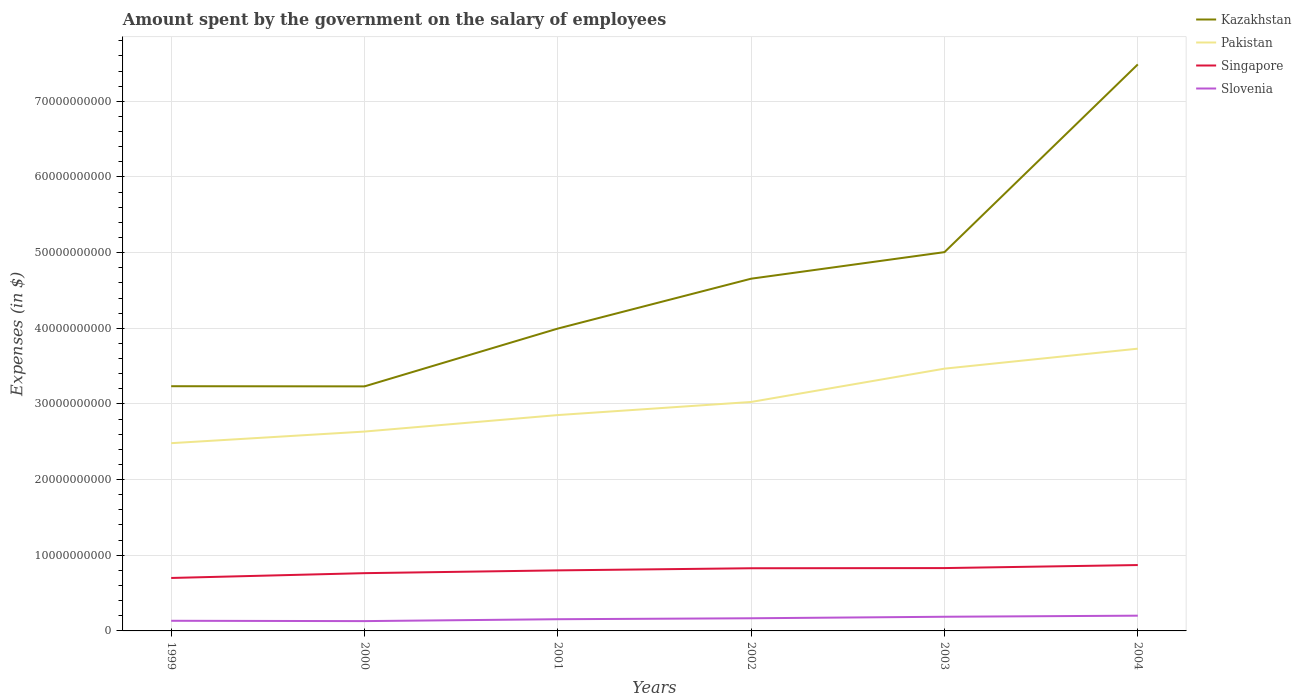How many different coloured lines are there?
Your answer should be compact. 4. Across all years, what is the maximum amount spent on the salary of employees by the government in Slovenia?
Offer a very short reply. 1.30e+09. What is the total amount spent on the salary of employees by the government in Singapore in the graph?
Your response must be concise. -6.35e+08. What is the difference between the highest and the second highest amount spent on the salary of employees by the government in Singapore?
Your response must be concise. 1.71e+09. Does the graph contain any zero values?
Provide a short and direct response. No. Does the graph contain grids?
Provide a short and direct response. Yes. How many legend labels are there?
Your answer should be very brief. 4. What is the title of the graph?
Provide a succinct answer. Amount spent by the government on the salary of employees. Does "Pakistan" appear as one of the legend labels in the graph?
Make the answer very short. Yes. What is the label or title of the X-axis?
Provide a succinct answer. Years. What is the label or title of the Y-axis?
Keep it short and to the point. Expenses (in $). What is the Expenses (in $) of Kazakhstan in 1999?
Ensure brevity in your answer.  3.23e+1. What is the Expenses (in $) in Pakistan in 1999?
Your answer should be compact. 2.48e+1. What is the Expenses (in $) in Singapore in 1999?
Offer a very short reply. 7.00e+09. What is the Expenses (in $) in Slovenia in 1999?
Provide a short and direct response. 1.34e+09. What is the Expenses (in $) in Kazakhstan in 2000?
Give a very brief answer. 3.23e+1. What is the Expenses (in $) in Pakistan in 2000?
Your answer should be very brief. 2.64e+1. What is the Expenses (in $) of Singapore in 2000?
Offer a very short reply. 7.63e+09. What is the Expenses (in $) of Slovenia in 2000?
Give a very brief answer. 1.30e+09. What is the Expenses (in $) in Kazakhstan in 2001?
Make the answer very short. 4.00e+1. What is the Expenses (in $) of Pakistan in 2001?
Your response must be concise. 2.85e+1. What is the Expenses (in $) of Singapore in 2001?
Make the answer very short. 8.00e+09. What is the Expenses (in $) of Slovenia in 2001?
Provide a short and direct response. 1.55e+09. What is the Expenses (in $) in Kazakhstan in 2002?
Provide a short and direct response. 4.66e+1. What is the Expenses (in $) of Pakistan in 2002?
Your response must be concise. 3.03e+1. What is the Expenses (in $) in Singapore in 2002?
Offer a very short reply. 8.28e+09. What is the Expenses (in $) in Slovenia in 2002?
Your answer should be very brief. 1.67e+09. What is the Expenses (in $) of Kazakhstan in 2003?
Provide a short and direct response. 5.01e+1. What is the Expenses (in $) of Pakistan in 2003?
Offer a terse response. 3.47e+1. What is the Expenses (in $) in Singapore in 2003?
Make the answer very short. 8.31e+09. What is the Expenses (in $) of Slovenia in 2003?
Provide a succinct answer. 1.87e+09. What is the Expenses (in $) of Kazakhstan in 2004?
Provide a succinct answer. 7.49e+1. What is the Expenses (in $) of Pakistan in 2004?
Provide a succinct answer. 3.73e+1. What is the Expenses (in $) in Singapore in 2004?
Your answer should be very brief. 8.71e+09. What is the Expenses (in $) in Slovenia in 2004?
Provide a succinct answer. 2.02e+09. Across all years, what is the maximum Expenses (in $) in Kazakhstan?
Keep it short and to the point. 7.49e+1. Across all years, what is the maximum Expenses (in $) in Pakistan?
Offer a very short reply. 3.73e+1. Across all years, what is the maximum Expenses (in $) in Singapore?
Provide a succinct answer. 8.71e+09. Across all years, what is the maximum Expenses (in $) in Slovenia?
Offer a very short reply. 2.02e+09. Across all years, what is the minimum Expenses (in $) in Kazakhstan?
Ensure brevity in your answer.  3.23e+1. Across all years, what is the minimum Expenses (in $) in Pakistan?
Offer a terse response. 2.48e+1. Across all years, what is the minimum Expenses (in $) of Singapore?
Make the answer very short. 7.00e+09. Across all years, what is the minimum Expenses (in $) in Slovenia?
Your answer should be very brief. 1.30e+09. What is the total Expenses (in $) in Kazakhstan in the graph?
Offer a very short reply. 2.76e+11. What is the total Expenses (in $) in Pakistan in the graph?
Provide a short and direct response. 1.82e+11. What is the total Expenses (in $) of Singapore in the graph?
Keep it short and to the point. 4.79e+1. What is the total Expenses (in $) of Slovenia in the graph?
Your answer should be compact. 9.75e+09. What is the difference between the Expenses (in $) in Kazakhstan in 1999 and that in 2000?
Provide a succinct answer. 2.18e+07. What is the difference between the Expenses (in $) of Pakistan in 1999 and that in 2000?
Keep it short and to the point. -1.54e+09. What is the difference between the Expenses (in $) of Singapore in 1999 and that in 2000?
Offer a terse response. -6.35e+08. What is the difference between the Expenses (in $) in Slovenia in 1999 and that in 2000?
Your response must be concise. 4.36e+07. What is the difference between the Expenses (in $) of Kazakhstan in 1999 and that in 2001?
Your answer should be compact. -7.62e+09. What is the difference between the Expenses (in $) of Pakistan in 1999 and that in 2001?
Your answer should be compact. -3.72e+09. What is the difference between the Expenses (in $) of Singapore in 1999 and that in 2001?
Your response must be concise. -1.00e+09. What is the difference between the Expenses (in $) of Slovenia in 1999 and that in 2001?
Provide a succinct answer. -2.05e+08. What is the difference between the Expenses (in $) of Kazakhstan in 1999 and that in 2002?
Give a very brief answer. -1.42e+1. What is the difference between the Expenses (in $) of Pakistan in 1999 and that in 2002?
Make the answer very short. -5.45e+09. What is the difference between the Expenses (in $) in Singapore in 1999 and that in 2002?
Offer a very short reply. -1.28e+09. What is the difference between the Expenses (in $) of Slovenia in 1999 and that in 2002?
Give a very brief answer. -3.32e+08. What is the difference between the Expenses (in $) of Kazakhstan in 1999 and that in 2003?
Give a very brief answer. -1.77e+1. What is the difference between the Expenses (in $) of Pakistan in 1999 and that in 2003?
Offer a terse response. -9.85e+09. What is the difference between the Expenses (in $) of Singapore in 1999 and that in 2003?
Offer a terse response. -1.31e+09. What is the difference between the Expenses (in $) of Slovenia in 1999 and that in 2003?
Offer a very short reply. -5.33e+08. What is the difference between the Expenses (in $) of Kazakhstan in 1999 and that in 2004?
Your answer should be compact. -4.25e+1. What is the difference between the Expenses (in $) in Pakistan in 1999 and that in 2004?
Ensure brevity in your answer.  -1.25e+1. What is the difference between the Expenses (in $) in Singapore in 1999 and that in 2004?
Make the answer very short. -1.71e+09. What is the difference between the Expenses (in $) in Slovenia in 1999 and that in 2004?
Provide a short and direct response. -6.75e+08. What is the difference between the Expenses (in $) of Kazakhstan in 2000 and that in 2001?
Keep it short and to the point. -7.64e+09. What is the difference between the Expenses (in $) in Pakistan in 2000 and that in 2001?
Provide a short and direct response. -2.18e+09. What is the difference between the Expenses (in $) of Singapore in 2000 and that in 2001?
Offer a terse response. -3.69e+08. What is the difference between the Expenses (in $) in Slovenia in 2000 and that in 2001?
Give a very brief answer. -2.49e+08. What is the difference between the Expenses (in $) of Kazakhstan in 2000 and that in 2002?
Your answer should be compact. -1.42e+1. What is the difference between the Expenses (in $) of Pakistan in 2000 and that in 2002?
Offer a very short reply. -3.91e+09. What is the difference between the Expenses (in $) of Singapore in 2000 and that in 2002?
Ensure brevity in your answer.  -6.49e+08. What is the difference between the Expenses (in $) in Slovenia in 2000 and that in 2002?
Your answer should be compact. -3.76e+08. What is the difference between the Expenses (in $) of Kazakhstan in 2000 and that in 2003?
Give a very brief answer. -1.77e+1. What is the difference between the Expenses (in $) of Pakistan in 2000 and that in 2003?
Give a very brief answer. -8.32e+09. What is the difference between the Expenses (in $) in Singapore in 2000 and that in 2003?
Your answer should be compact. -6.72e+08. What is the difference between the Expenses (in $) of Slovenia in 2000 and that in 2003?
Make the answer very short. -5.77e+08. What is the difference between the Expenses (in $) in Kazakhstan in 2000 and that in 2004?
Provide a succinct answer. -4.26e+1. What is the difference between the Expenses (in $) of Pakistan in 2000 and that in 2004?
Give a very brief answer. -1.10e+1. What is the difference between the Expenses (in $) in Singapore in 2000 and that in 2004?
Ensure brevity in your answer.  -1.07e+09. What is the difference between the Expenses (in $) in Slovenia in 2000 and that in 2004?
Give a very brief answer. -7.19e+08. What is the difference between the Expenses (in $) in Kazakhstan in 2001 and that in 2002?
Your response must be concise. -6.59e+09. What is the difference between the Expenses (in $) of Pakistan in 2001 and that in 2002?
Your response must be concise. -1.73e+09. What is the difference between the Expenses (in $) in Singapore in 2001 and that in 2002?
Provide a short and direct response. -2.80e+08. What is the difference between the Expenses (in $) of Slovenia in 2001 and that in 2002?
Keep it short and to the point. -1.27e+08. What is the difference between the Expenses (in $) in Kazakhstan in 2001 and that in 2003?
Offer a terse response. -1.01e+1. What is the difference between the Expenses (in $) in Pakistan in 2001 and that in 2003?
Give a very brief answer. -6.14e+09. What is the difference between the Expenses (in $) of Singapore in 2001 and that in 2003?
Make the answer very short. -3.03e+08. What is the difference between the Expenses (in $) in Slovenia in 2001 and that in 2003?
Provide a short and direct response. -3.28e+08. What is the difference between the Expenses (in $) of Kazakhstan in 2001 and that in 2004?
Keep it short and to the point. -3.49e+1. What is the difference between the Expenses (in $) in Pakistan in 2001 and that in 2004?
Offer a terse response. -8.78e+09. What is the difference between the Expenses (in $) of Singapore in 2001 and that in 2004?
Your answer should be compact. -7.03e+08. What is the difference between the Expenses (in $) in Slovenia in 2001 and that in 2004?
Make the answer very short. -4.70e+08. What is the difference between the Expenses (in $) in Kazakhstan in 2002 and that in 2003?
Give a very brief answer. -3.51e+09. What is the difference between the Expenses (in $) of Pakistan in 2002 and that in 2003?
Your answer should be very brief. -4.40e+09. What is the difference between the Expenses (in $) of Singapore in 2002 and that in 2003?
Offer a terse response. -2.30e+07. What is the difference between the Expenses (in $) of Slovenia in 2002 and that in 2003?
Make the answer very short. -2.01e+08. What is the difference between the Expenses (in $) in Kazakhstan in 2002 and that in 2004?
Your response must be concise. -2.83e+1. What is the difference between the Expenses (in $) of Pakistan in 2002 and that in 2004?
Provide a short and direct response. -7.04e+09. What is the difference between the Expenses (in $) in Singapore in 2002 and that in 2004?
Provide a short and direct response. -4.23e+08. What is the difference between the Expenses (in $) of Slovenia in 2002 and that in 2004?
Make the answer very short. -3.43e+08. What is the difference between the Expenses (in $) of Kazakhstan in 2003 and that in 2004?
Make the answer very short. -2.48e+1. What is the difference between the Expenses (in $) in Pakistan in 2003 and that in 2004?
Offer a very short reply. -2.64e+09. What is the difference between the Expenses (in $) of Singapore in 2003 and that in 2004?
Provide a succinct answer. -4.00e+08. What is the difference between the Expenses (in $) of Slovenia in 2003 and that in 2004?
Offer a terse response. -1.42e+08. What is the difference between the Expenses (in $) in Kazakhstan in 1999 and the Expenses (in $) in Pakistan in 2000?
Give a very brief answer. 5.99e+09. What is the difference between the Expenses (in $) of Kazakhstan in 1999 and the Expenses (in $) of Singapore in 2000?
Your answer should be compact. 2.47e+1. What is the difference between the Expenses (in $) of Kazakhstan in 1999 and the Expenses (in $) of Slovenia in 2000?
Give a very brief answer. 3.10e+1. What is the difference between the Expenses (in $) in Pakistan in 1999 and the Expenses (in $) in Singapore in 2000?
Make the answer very short. 1.72e+1. What is the difference between the Expenses (in $) of Pakistan in 1999 and the Expenses (in $) of Slovenia in 2000?
Offer a terse response. 2.35e+1. What is the difference between the Expenses (in $) in Singapore in 1999 and the Expenses (in $) in Slovenia in 2000?
Make the answer very short. 5.70e+09. What is the difference between the Expenses (in $) of Kazakhstan in 1999 and the Expenses (in $) of Pakistan in 2001?
Provide a succinct answer. 3.81e+09. What is the difference between the Expenses (in $) in Kazakhstan in 1999 and the Expenses (in $) in Singapore in 2001?
Offer a terse response. 2.43e+1. What is the difference between the Expenses (in $) in Kazakhstan in 1999 and the Expenses (in $) in Slovenia in 2001?
Make the answer very short. 3.08e+1. What is the difference between the Expenses (in $) in Pakistan in 1999 and the Expenses (in $) in Singapore in 2001?
Ensure brevity in your answer.  1.68e+1. What is the difference between the Expenses (in $) of Pakistan in 1999 and the Expenses (in $) of Slovenia in 2001?
Your response must be concise. 2.33e+1. What is the difference between the Expenses (in $) in Singapore in 1999 and the Expenses (in $) in Slovenia in 2001?
Offer a very short reply. 5.45e+09. What is the difference between the Expenses (in $) in Kazakhstan in 1999 and the Expenses (in $) in Pakistan in 2002?
Provide a short and direct response. 2.08e+09. What is the difference between the Expenses (in $) in Kazakhstan in 1999 and the Expenses (in $) in Singapore in 2002?
Ensure brevity in your answer.  2.41e+1. What is the difference between the Expenses (in $) of Kazakhstan in 1999 and the Expenses (in $) of Slovenia in 2002?
Offer a very short reply. 3.07e+1. What is the difference between the Expenses (in $) in Pakistan in 1999 and the Expenses (in $) in Singapore in 2002?
Your response must be concise. 1.65e+1. What is the difference between the Expenses (in $) of Pakistan in 1999 and the Expenses (in $) of Slovenia in 2002?
Offer a very short reply. 2.31e+1. What is the difference between the Expenses (in $) in Singapore in 1999 and the Expenses (in $) in Slovenia in 2002?
Ensure brevity in your answer.  5.33e+09. What is the difference between the Expenses (in $) of Kazakhstan in 1999 and the Expenses (in $) of Pakistan in 2003?
Your answer should be very brief. -2.32e+09. What is the difference between the Expenses (in $) in Kazakhstan in 1999 and the Expenses (in $) in Singapore in 2003?
Keep it short and to the point. 2.40e+1. What is the difference between the Expenses (in $) in Kazakhstan in 1999 and the Expenses (in $) in Slovenia in 2003?
Offer a very short reply. 3.05e+1. What is the difference between the Expenses (in $) in Pakistan in 1999 and the Expenses (in $) in Singapore in 2003?
Offer a very short reply. 1.65e+1. What is the difference between the Expenses (in $) of Pakistan in 1999 and the Expenses (in $) of Slovenia in 2003?
Offer a terse response. 2.29e+1. What is the difference between the Expenses (in $) in Singapore in 1999 and the Expenses (in $) in Slovenia in 2003?
Offer a terse response. 5.13e+09. What is the difference between the Expenses (in $) of Kazakhstan in 1999 and the Expenses (in $) of Pakistan in 2004?
Give a very brief answer. -4.96e+09. What is the difference between the Expenses (in $) of Kazakhstan in 1999 and the Expenses (in $) of Singapore in 2004?
Offer a terse response. 2.36e+1. What is the difference between the Expenses (in $) of Kazakhstan in 1999 and the Expenses (in $) of Slovenia in 2004?
Ensure brevity in your answer.  3.03e+1. What is the difference between the Expenses (in $) of Pakistan in 1999 and the Expenses (in $) of Singapore in 2004?
Your answer should be very brief. 1.61e+1. What is the difference between the Expenses (in $) in Pakistan in 1999 and the Expenses (in $) in Slovenia in 2004?
Make the answer very short. 2.28e+1. What is the difference between the Expenses (in $) of Singapore in 1999 and the Expenses (in $) of Slovenia in 2004?
Ensure brevity in your answer.  4.98e+09. What is the difference between the Expenses (in $) in Kazakhstan in 2000 and the Expenses (in $) in Pakistan in 2001?
Give a very brief answer. 3.79e+09. What is the difference between the Expenses (in $) of Kazakhstan in 2000 and the Expenses (in $) of Singapore in 2001?
Your answer should be compact. 2.43e+1. What is the difference between the Expenses (in $) of Kazakhstan in 2000 and the Expenses (in $) of Slovenia in 2001?
Offer a very short reply. 3.08e+1. What is the difference between the Expenses (in $) in Pakistan in 2000 and the Expenses (in $) in Singapore in 2001?
Your answer should be very brief. 1.83e+1. What is the difference between the Expenses (in $) in Pakistan in 2000 and the Expenses (in $) in Slovenia in 2001?
Your answer should be compact. 2.48e+1. What is the difference between the Expenses (in $) in Singapore in 2000 and the Expenses (in $) in Slovenia in 2001?
Ensure brevity in your answer.  6.09e+09. What is the difference between the Expenses (in $) of Kazakhstan in 2000 and the Expenses (in $) of Pakistan in 2002?
Your response must be concise. 2.06e+09. What is the difference between the Expenses (in $) in Kazakhstan in 2000 and the Expenses (in $) in Singapore in 2002?
Your answer should be compact. 2.40e+1. What is the difference between the Expenses (in $) of Kazakhstan in 2000 and the Expenses (in $) of Slovenia in 2002?
Make the answer very short. 3.06e+1. What is the difference between the Expenses (in $) in Pakistan in 2000 and the Expenses (in $) in Singapore in 2002?
Give a very brief answer. 1.81e+1. What is the difference between the Expenses (in $) of Pakistan in 2000 and the Expenses (in $) of Slovenia in 2002?
Provide a succinct answer. 2.47e+1. What is the difference between the Expenses (in $) of Singapore in 2000 and the Expenses (in $) of Slovenia in 2002?
Make the answer very short. 5.96e+09. What is the difference between the Expenses (in $) in Kazakhstan in 2000 and the Expenses (in $) in Pakistan in 2003?
Your response must be concise. -2.34e+09. What is the difference between the Expenses (in $) of Kazakhstan in 2000 and the Expenses (in $) of Singapore in 2003?
Make the answer very short. 2.40e+1. What is the difference between the Expenses (in $) of Kazakhstan in 2000 and the Expenses (in $) of Slovenia in 2003?
Keep it short and to the point. 3.04e+1. What is the difference between the Expenses (in $) in Pakistan in 2000 and the Expenses (in $) in Singapore in 2003?
Your answer should be very brief. 1.80e+1. What is the difference between the Expenses (in $) in Pakistan in 2000 and the Expenses (in $) in Slovenia in 2003?
Give a very brief answer. 2.45e+1. What is the difference between the Expenses (in $) in Singapore in 2000 and the Expenses (in $) in Slovenia in 2003?
Give a very brief answer. 5.76e+09. What is the difference between the Expenses (in $) in Kazakhstan in 2000 and the Expenses (in $) in Pakistan in 2004?
Your response must be concise. -4.98e+09. What is the difference between the Expenses (in $) of Kazakhstan in 2000 and the Expenses (in $) of Singapore in 2004?
Offer a very short reply. 2.36e+1. What is the difference between the Expenses (in $) of Kazakhstan in 2000 and the Expenses (in $) of Slovenia in 2004?
Offer a very short reply. 3.03e+1. What is the difference between the Expenses (in $) in Pakistan in 2000 and the Expenses (in $) in Singapore in 2004?
Provide a short and direct response. 1.76e+1. What is the difference between the Expenses (in $) in Pakistan in 2000 and the Expenses (in $) in Slovenia in 2004?
Make the answer very short. 2.43e+1. What is the difference between the Expenses (in $) of Singapore in 2000 and the Expenses (in $) of Slovenia in 2004?
Keep it short and to the point. 5.62e+09. What is the difference between the Expenses (in $) of Kazakhstan in 2001 and the Expenses (in $) of Pakistan in 2002?
Offer a very short reply. 9.70e+09. What is the difference between the Expenses (in $) in Kazakhstan in 2001 and the Expenses (in $) in Singapore in 2002?
Make the answer very short. 3.17e+1. What is the difference between the Expenses (in $) of Kazakhstan in 2001 and the Expenses (in $) of Slovenia in 2002?
Ensure brevity in your answer.  3.83e+1. What is the difference between the Expenses (in $) in Pakistan in 2001 and the Expenses (in $) in Singapore in 2002?
Offer a very short reply. 2.02e+1. What is the difference between the Expenses (in $) in Pakistan in 2001 and the Expenses (in $) in Slovenia in 2002?
Your answer should be very brief. 2.69e+1. What is the difference between the Expenses (in $) in Singapore in 2001 and the Expenses (in $) in Slovenia in 2002?
Give a very brief answer. 6.33e+09. What is the difference between the Expenses (in $) of Kazakhstan in 2001 and the Expenses (in $) of Pakistan in 2003?
Your answer should be very brief. 5.30e+09. What is the difference between the Expenses (in $) in Kazakhstan in 2001 and the Expenses (in $) in Singapore in 2003?
Ensure brevity in your answer.  3.17e+1. What is the difference between the Expenses (in $) in Kazakhstan in 2001 and the Expenses (in $) in Slovenia in 2003?
Your answer should be very brief. 3.81e+1. What is the difference between the Expenses (in $) of Pakistan in 2001 and the Expenses (in $) of Singapore in 2003?
Your answer should be compact. 2.02e+1. What is the difference between the Expenses (in $) in Pakistan in 2001 and the Expenses (in $) in Slovenia in 2003?
Provide a succinct answer. 2.67e+1. What is the difference between the Expenses (in $) in Singapore in 2001 and the Expenses (in $) in Slovenia in 2003?
Offer a very short reply. 6.13e+09. What is the difference between the Expenses (in $) in Kazakhstan in 2001 and the Expenses (in $) in Pakistan in 2004?
Your response must be concise. 2.66e+09. What is the difference between the Expenses (in $) of Kazakhstan in 2001 and the Expenses (in $) of Singapore in 2004?
Provide a succinct answer. 3.13e+1. What is the difference between the Expenses (in $) in Kazakhstan in 2001 and the Expenses (in $) in Slovenia in 2004?
Give a very brief answer. 3.79e+1. What is the difference between the Expenses (in $) in Pakistan in 2001 and the Expenses (in $) in Singapore in 2004?
Offer a terse response. 1.98e+1. What is the difference between the Expenses (in $) in Pakistan in 2001 and the Expenses (in $) in Slovenia in 2004?
Provide a short and direct response. 2.65e+1. What is the difference between the Expenses (in $) in Singapore in 2001 and the Expenses (in $) in Slovenia in 2004?
Give a very brief answer. 5.99e+09. What is the difference between the Expenses (in $) of Kazakhstan in 2002 and the Expenses (in $) of Pakistan in 2003?
Keep it short and to the point. 1.19e+1. What is the difference between the Expenses (in $) of Kazakhstan in 2002 and the Expenses (in $) of Singapore in 2003?
Your answer should be very brief. 3.82e+1. What is the difference between the Expenses (in $) of Kazakhstan in 2002 and the Expenses (in $) of Slovenia in 2003?
Ensure brevity in your answer.  4.47e+1. What is the difference between the Expenses (in $) in Pakistan in 2002 and the Expenses (in $) in Singapore in 2003?
Your response must be concise. 2.20e+1. What is the difference between the Expenses (in $) of Pakistan in 2002 and the Expenses (in $) of Slovenia in 2003?
Provide a succinct answer. 2.84e+1. What is the difference between the Expenses (in $) of Singapore in 2002 and the Expenses (in $) of Slovenia in 2003?
Make the answer very short. 6.41e+09. What is the difference between the Expenses (in $) in Kazakhstan in 2002 and the Expenses (in $) in Pakistan in 2004?
Make the answer very short. 9.25e+09. What is the difference between the Expenses (in $) of Kazakhstan in 2002 and the Expenses (in $) of Singapore in 2004?
Make the answer very short. 3.78e+1. What is the difference between the Expenses (in $) in Kazakhstan in 2002 and the Expenses (in $) in Slovenia in 2004?
Keep it short and to the point. 4.45e+1. What is the difference between the Expenses (in $) of Pakistan in 2002 and the Expenses (in $) of Singapore in 2004?
Offer a terse response. 2.16e+1. What is the difference between the Expenses (in $) of Pakistan in 2002 and the Expenses (in $) of Slovenia in 2004?
Provide a short and direct response. 2.82e+1. What is the difference between the Expenses (in $) of Singapore in 2002 and the Expenses (in $) of Slovenia in 2004?
Make the answer very short. 6.27e+09. What is the difference between the Expenses (in $) in Kazakhstan in 2003 and the Expenses (in $) in Pakistan in 2004?
Provide a short and direct response. 1.28e+1. What is the difference between the Expenses (in $) of Kazakhstan in 2003 and the Expenses (in $) of Singapore in 2004?
Offer a very short reply. 4.14e+1. What is the difference between the Expenses (in $) of Kazakhstan in 2003 and the Expenses (in $) of Slovenia in 2004?
Offer a terse response. 4.80e+1. What is the difference between the Expenses (in $) of Pakistan in 2003 and the Expenses (in $) of Singapore in 2004?
Your answer should be compact. 2.60e+1. What is the difference between the Expenses (in $) in Pakistan in 2003 and the Expenses (in $) in Slovenia in 2004?
Provide a short and direct response. 3.26e+1. What is the difference between the Expenses (in $) of Singapore in 2003 and the Expenses (in $) of Slovenia in 2004?
Provide a succinct answer. 6.29e+09. What is the average Expenses (in $) in Kazakhstan per year?
Your response must be concise. 4.60e+1. What is the average Expenses (in $) in Pakistan per year?
Ensure brevity in your answer.  3.03e+1. What is the average Expenses (in $) of Singapore per year?
Provide a succinct answer. 7.99e+09. What is the average Expenses (in $) of Slovenia per year?
Ensure brevity in your answer.  1.62e+09. In the year 1999, what is the difference between the Expenses (in $) of Kazakhstan and Expenses (in $) of Pakistan?
Offer a very short reply. 7.53e+09. In the year 1999, what is the difference between the Expenses (in $) in Kazakhstan and Expenses (in $) in Singapore?
Offer a very short reply. 2.53e+1. In the year 1999, what is the difference between the Expenses (in $) in Kazakhstan and Expenses (in $) in Slovenia?
Provide a succinct answer. 3.10e+1. In the year 1999, what is the difference between the Expenses (in $) in Pakistan and Expenses (in $) in Singapore?
Offer a terse response. 1.78e+1. In the year 1999, what is the difference between the Expenses (in $) of Pakistan and Expenses (in $) of Slovenia?
Give a very brief answer. 2.35e+1. In the year 1999, what is the difference between the Expenses (in $) in Singapore and Expenses (in $) in Slovenia?
Your response must be concise. 5.66e+09. In the year 2000, what is the difference between the Expenses (in $) of Kazakhstan and Expenses (in $) of Pakistan?
Your answer should be compact. 5.97e+09. In the year 2000, what is the difference between the Expenses (in $) in Kazakhstan and Expenses (in $) in Singapore?
Provide a succinct answer. 2.47e+1. In the year 2000, what is the difference between the Expenses (in $) in Kazakhstan and Expenses (in $) in Slovenia?
Offer a terse response. 3.10e+1. In the year 2000, what is the difference between the Expenses (in $) of Pakistan and Expenses (in $) of Singapore?
Your answer should be compact. 1.87e+1. In the year 2000, what is the difference between the Expenses (in $) of Pakistan and Expenses (in $) of Slovenia?
Your answer should be compact. 2.51e+1. In the year 2000, what is the difference between the Expenses (in $) of Singapore and Expenses (in $) of Slovenia?
Provide a short and direct response. 6.34e+09. In the year 2001, what is the difference between the Expenses (in $) in Kazakhstan and Expenses (in $) in Pakistan?
Your answer should be very brief. 1.14e+1. In the year 2001, what is the difference between the Expenses (in $) of Kazakhstan and Expenses (in $) of Singapore?
Keep it short and to the point. 3.20e+1. In the year 2001, what is the difference between the Expenses (in $) of Kazakhstan and Expenses (in $) of Slovenia?
Provide a short and direct response. 3.84e+1. In the year 2001, what is the difference between the Expenses (in $) in Pakistan and Expenses (in $) in Singapore?
Offer a very short reply. 2.05e+1. In the year 2001, what is the difference between the Expenses (in $) in Pakistan and Expenses (in $) in Slovenia?
Offer a very short reply. 2.70e+1. In the year 2001, what is the difference between the Expenses (in $) of Singapore and Expenses (in $) of Slovenia?
Provide a short and direct response. 6.46e+09. In the year 2002, what is the difference between the Expenses (in $) in Kazakhstan and Expenses (in $) in Pakistan?
Make the answer very short. 1.63e+1. In the year 2002, what is the difference between the Expenses (in $) of Kazakhstan and Expenses (in $) of Singapore?
Ensure brevity in your answer.  3.83e+1. In the year 2002, what is the difference between the Expenses (in $) of Kazakhstan and Expenses (in $) of Slovenia?
Keep it short and to the point. 4.49e+1. In the year 2002, what is the difference between the Expenses (in $) in Pakistan and Expenses (in $) in Singapore?
Ensure brevity in your answer.  2.20e+1. In the year 2002, what is the difference between the Expenses (in $) in Pakistan and Expenses (in $) in Slovenia?
Offer a terse response. 2.86e+1. In the year 2002, what is the difference between the Expenses (in $) of Singapore and Expenses (in $) of Slovenia?
Offer a terse response. 6.61e+09. In the year 2003, what is the difference between the Expenses (in $) in Kazakhstan and Expenses (in $) in Pakistan?
Your response must be concise. 1.54e+1. In the year 2003, what is the difference between the Expenses (in $) in Kazakhstan and Expenses (in $) in Singapore?
Your answer should be compact. 4.18e+1. In the year 2003, what is the difference between the Expenses (in $) of Kazakhstan and Expenses (in $) of Slovenia?
Make the answer very short. 4.82e+1. In the year 2003, what is the difference between the Expenses (in $) of Pakistan and Expenses (in $) of Singapore?
Keep it short and to the point. 2.64e+1. In the year 2003, what is the difference between the Expenses (in $) of Pakistan and Expenses (in $) of Slovenia?
Give a very brief answer. 3.28e+1. In the year 2003, what is the difference between the Expenses (in $) of Singapore and Expenses (in $) of Slovenia?
Offer a terse response. 6.43e+09. In the year 2004, what is the difference between the Expenses (in $) of Kazakhstan and Expenses (in $) of Pakistan?
Ensure brevity in your answer.  3.76e+1. In the year 2004, what is the difference between the Expenses (in $) of Kazakhstan and Expenses (in $) of Singapore?
Your answer should be compact. 6.62e+1. In the year 2004, what is the difference between the Expenses (in $) of Kazakhstan and Expenses (in $) of Slovenia?
Ensure brevity in your answer.  7.29e+1. In the year 2004, what is the difference between the Expenses (in $) in Pakistan and Expenses (in $) in Singapore?
Your response must be concise. 2.86e+1. In the year 2004, what is the difference between the Expenses (in $) in Pakistan and Expenses (in $) in Slovenia?
Offer a very short reply. 3.53e+1. In the year 2004, what is the difference between the Expenses (in $) of Singapore and Expenses (in $) of Slovenia?
Your answer should be compact. 6.69e+09. What is the ratio of the Expenses (in $) in Kazakhstan in 1999 to that in 2000?
Offer a very short reply. 1. What is the ratio of the Expenses (in $) in Pakistan in 1999 to that in 2000?
Make the answer very short. 0.94. What is the ratio of the Expenses (in $) of Singapore in 1999 to that in 2000?
Your answer should be compact. 0.92. What is the ratio of the Expenses (in $) in Slovenia in 1999 to that in 2000?
Your answer should be compact. 1.03. What is the ratio of the Expenses (in $) of Kazakhstan in 1999 to that in 2001?
Provide a succinct answer. 0.81. What is the ratio of the Expenses (in $) of Pakistan in 1999 to that in 2001?
Offer a very short reply. 0.87. What is the ratio of the Expenses (in $) of Singapore in 1999 to that in 2001?
Provide a succinct answer. 0.87. What is the ratio of the Expenses (in $) of Slovenia in 1999 to that in 2001?
Make the answer very short. 0.87. What is the ratio of the Expenses (in $) of Kazakhstan in 1999 to that in 2002?
Ensure brevity in your answer.  0.69. What is the ratio of the Expenses (in $) of Pakistan in 1999 to that in 2002?
Your response must be concise. 0.82. What is the ratio of the Expenses (in $) of Singapore in 1999 to that in 2002?
Your answer should be compact. 0.84. What is the ratio of the Expenses (in $) of Slovenia in 1999 to that in 2002?
Your response must be concise. 0.8. What is the ratio of the Expenses (in $) of Kazakhstan in 1999 to that in 2003?
Provide a short and direct response. 0.65. What is the ratio of the Expenses (in $) in Pakistan in 1999 to that in 2003?
Give a very brief answer. 0.72. What is the ratio of the Expenses (in $) in Singapore in 1999 to that in 2003?
Offer a very short reply. 0.84. What is the ratio of the Expenses (in $) in Slovenia in 1999 to that in 2003?
Your answer should be very brief. 0.72. What is the ratio of the Expenses (in $) in Kazakhstan in 1999 to that in 2004?
Offer a very short reply. 0.43. What is the ratio of the Expenses (in $) of Pakistan in 1999 to that in 2004?
Keep it short and to the point. 0.67. What is the ratio of the Expenses (in $) in Singapore in 1999 to that in 2004?
Your answer should be very brief. 0.8. What is the ratio of the Expenses (in $) in Slovenia in 1999 to that in 2004?
Provide a short and direct response. 0.67. What is the ratio of the Expenses (in $) of Kazakhstan in 2000 to that in 2001?
Make the answer very short. 0.81. What is the ratio of the Expenses (in $) in Pakistan in 2000 to that in 2001?
Offer a terse response. 0.92. What is the ratio of the Expenses (in $) of Singapore in 2000 to that in 2001?
Give a very brief answer. 0.95. What is the ratio of the Expenses (in $) of Slovenia in 2000 to that in 2001?
Your answer should be compact. 0.84. What is the ratio of the Expenses (in $) in Kazakhstan in 2000 to that in 2002?
Provide a succinct answer. 0.69. What is the ratio of the Expenses (in $) of Pakistan in 2000 to that in 2002?
Ensure brevity in your answer.  0.87. What is the ratio of the Expenses (in $) in Singapore in 2000 to that in 2002?
Make the answer very short. 0.92. What is the ratio of the Expenses (in $) of Slovenia in 2000 to that in 2002?
Your answer should be very brief. 0.78. What is the ratio of the Expenses (in $) in Kazakhstan in 2000 to that in 2003?
Provide a short and direct response. 0.65. What is the ratio of the Expenses (in $) in Pakistan in 2000 to that in 2003?
Offer a very short reply. 0.76. What is the ratio of the Expenses (in $) in Singapore in 2000 to that in 2003?
Your response must be concise. 0.92. What is the ratio of the Expenses (in $) of Slovenia in 2000 to that in 2003?
Your response must be concise. 0.69. What is the ratio of the Expenses (in $) of Kazakhstan in 2000 to that in 2004?
Make the answer very short. 0.43. What is the ratio of the Expenses (in $) of Pakistan in 2000 to that in 2004?
Ensure brevity in your answer.  0.71. What is the ratio of the Expenses (in $) of Singapore in 2000 to that in 2004?
Make the answer very short. 0.88. What is the ratio of the Expenses (in $) in Slovenia in 2000 to that in 2004?
Offer a terse response. 0.64. What is the ratio of the Expenses (in $) in Kazakhstan in 2001 to that in 2002?
Make the answer very short. 0.86. What is the ratio of the Expenses (in $) of Pakistan in 2001 to that in 2002?
Ensure brevity in your answer.  0.94. What is the ratio of the Expenses (in $) of Singapore in 2001 to that in 2002?
Your answer should be compact. 0.97. What is the ratio of the Expenses (in $) of Slovenia in 2001 to that in 2002?
Ensure brevity in your answer.  0.92. What is the ratio of the Expenses (in $) in Kazakhstan in 2001 to that in 2003?
Ensure brevity in your answer.  0.8. What is the ratio of the Expenses (in $) of Pakistan in 2001 to that in 2003?
Provide a succinct answer. 0.82. What is the ratio of the Expenses (in $) of Singapore in 2001 to that in 2003?
Ensure brevity in your answer.  0.96. What is the ratio of the Expenses (in $) in Slovenia in 2001 to that in 2003?
Provide a short and direct response. 0.83. What is the ratio of the Expenses (in $) in Kazakhstan in 2001 to that in 2004?
Your response must be concise. 0.53. What is the ratio of the Expenses (in $) in Pakistan in 2001 to that in 2004?
Your response must be concise. 0.76. What is the ratio of the Expenses (in $) in Singapore in 2001 to that in 2004?
Your answer should be compact. 0.92. What is the ratio of the Expenses (in $) in Slovenia in 2001 to that in 2004?
Your answer should be compact. 0.77. What is the ratio of the Expenses (in $) in Kazakhstan in 2002 to that in 2003?
Offer a terse response. 0.93. What is the ratio of the Expenses (in $) of Pakistan in 2002 to that in 2003?
Ensure brevity in your answer.  0.87. What is the ratio of the Expenses (in $) of Singapore in 2002 to that in 2003?
Keep it short and to the point. 1. What is the ratio of the Expenses (in $) of Slovenia in 2002 to that in 2003?
Ensure brevity in your answer.  0.89. What is the ratio of the Expenses (in $) of Kazakhstan in 2002 to that in 2004?
Keep it short and to the point. 0.62. What is the ratio of the Expenses (in $) in Pakistan in 2002 to that in 2004?
Make the answer very short. 0.81. What is the ratio of the Expenses (in $) in Singapore in 2002 to that in 2004?
Make the answer very short. 0.95. What is the ratio of the Expenses (in $) of Slovenia in 2002 to that in 2004?
Offer a terse response. 0.83. What is the ratio of the Expenses (in $) of Kazakhstan in 2003 to that in 2004?
Offer a very short reply. 0.67. What is the ratio of the Expenses (in $) of Pakistan in 2003 to that in 2004?
Keep it short and to the point. 0.93. What is the ratio of the Expenses (in $) in Singapore in 2003 to that in 2004?
Your response must be concise. 0.95. What is the ratio of the Expenses (in $) in Slovenia in 2003 to that in 2004?
Keep it short and to the point. 0.93. What is the difference between the highest and the second highest Expenses (in $) of Kazakhstan?
Make the answer very short. 2.48e+1. What is the difference between the highest and the second highest Expenses (in $) in Pakistan?
Provide a succinct answer. 2.64e+09. What is the difference between the highest and the second highest Expenses (in $) of Singapore?
Offer a terse response. 4.00e+08. What is the difference between the highest and the second highest Expenses (in $) of Slovenia?
Your answer should be compact. 1.42e+08. What is the difference between the highest and the lowest Expenses (in $) in Kazakhstan?
Your response must be concise. 4.26e+1. What is the difference between the highest and the lowest Expenses (in $) in Pakistan?
Your response must be concise. 1.25e+1. What is the difference between the highest and the lowest Expenses (in $) of Singapore?
Offer a terse response. 1.71e+09. What is the difference between the highest and the lowest Expenses (in $) in Slovenia?
Your answer should be very brief. 7.19e+08. 